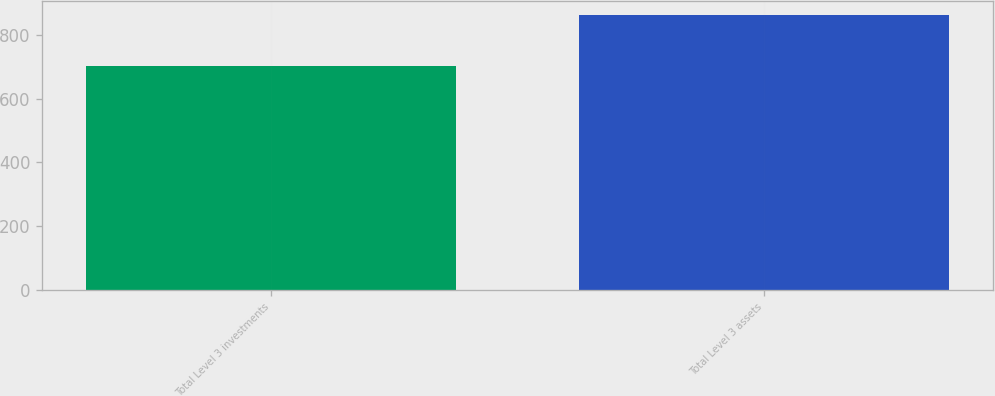Convert chart. <chart><loc_0><loc_0><loc_500><loc_500><bar_chart><fcel>Total Level 3 investments<fcel>Total Level 3 assets<nl><fcel>702<fcel>862<nl></chart> 